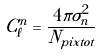Convert formula to latex. <formula><loc_0><loc_0><loc_500><loc_500>C _ { \ell } ^ { n } = \frac { 4 \pi \sigma _ { n } ^ { 2 } } { N _ { p i x t o t } }</formula> 